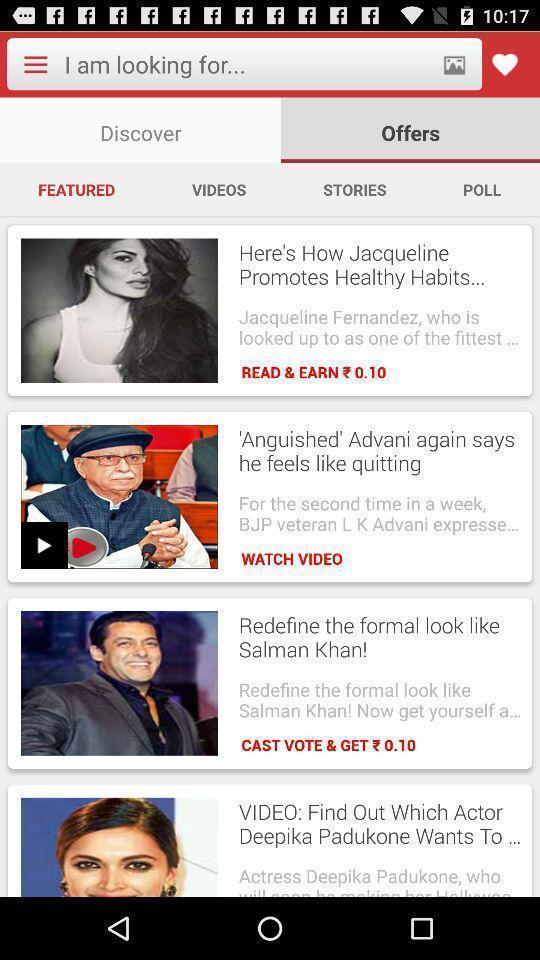What is the overall content of this screenshot? Screen shows various news in news app. 